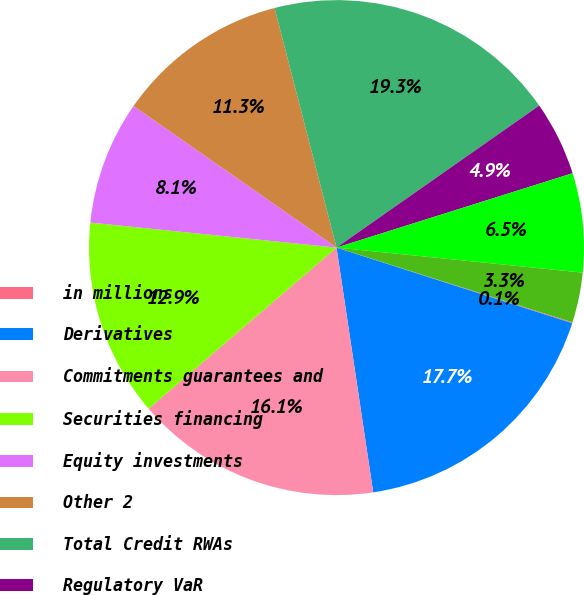Convert chart to OTSL. <chart><loc_0><loc_0><loc_500><loc_500><pie_chart><fcel>in millions<fcel>Derivatives<fcel>Commitments guarantees and<fcel>Securities financing<fcel>Equity investments<fcel>Other 2<fcel>Total Credit RWAs<fcel>Regulatory VaR<fcel>Stressed VaR<fcel>Incremental risk<nl><fcel>0.06%<fcel>17.69%<fcel>16.09%<fcel>12.89%<fcel>8.08%<fcel>11.28%<fcel>19.3%<fcel>4.87%<fcel>6.47%<fcel>3.27%<nl></chart> 